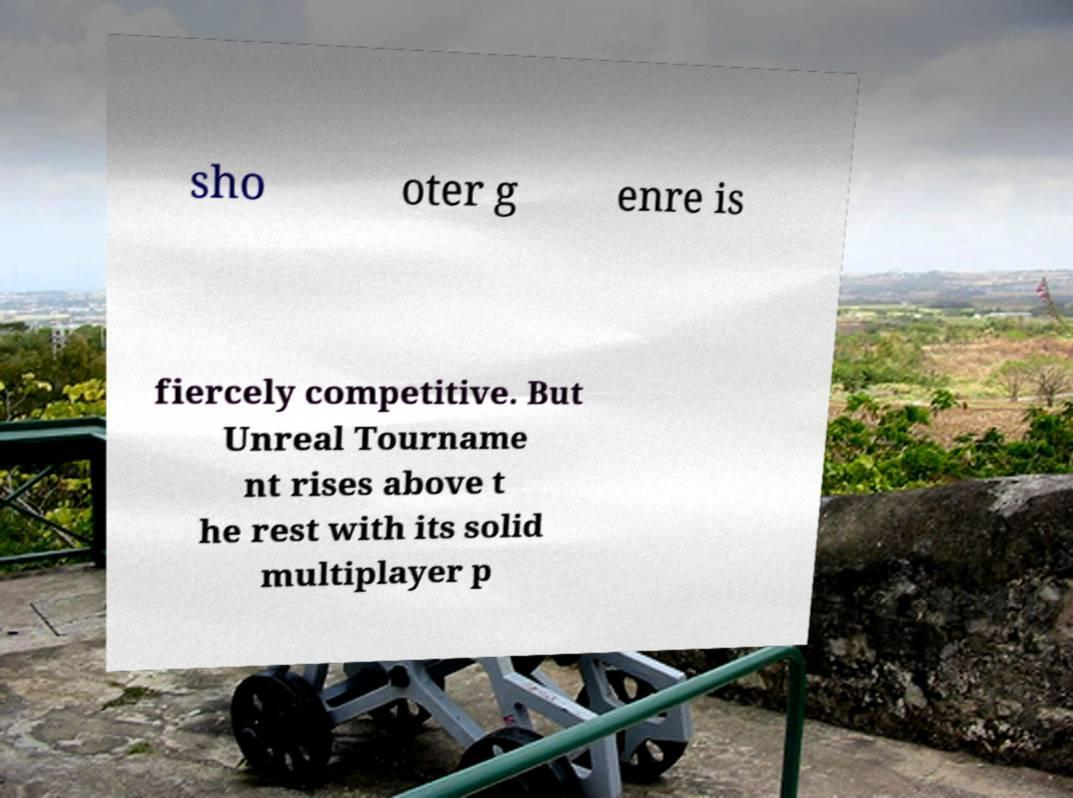I need the written content from this picture converted into text. Can you do that? sho oter g enre is fiercely competitive. But Unreal Tourname nt rises above t he rest with its solid multiplayer p 